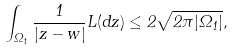<formula> <loc_0><loc_0><loc_500><loc_500>\int _ { \Omega _ { 1 } } \frac { 1 } { | z - w | } L ( d z ) \leq 2 \sqrt { 2 \pi | \Omega _ { 1 } | } ,</formula> 